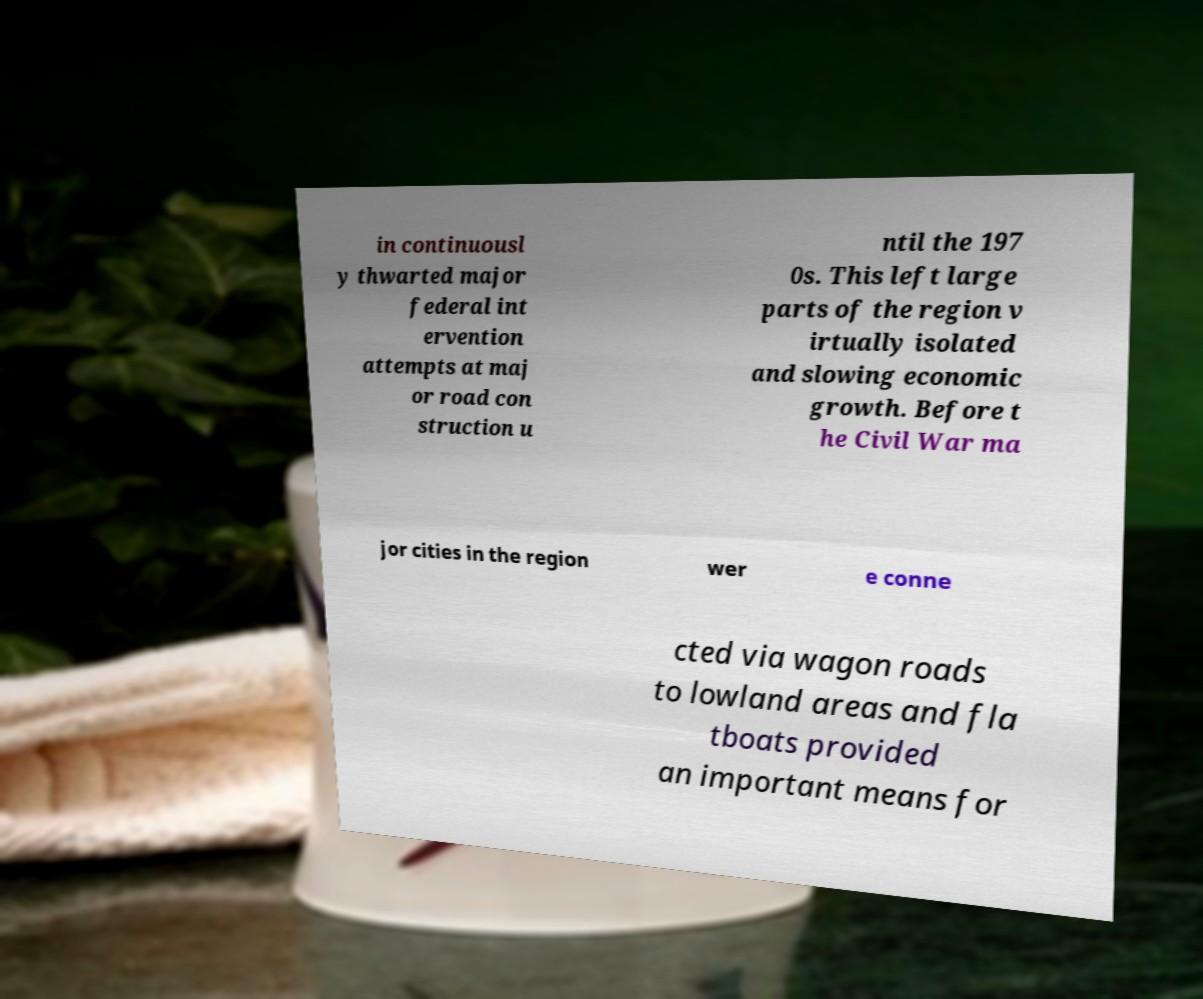Can you read and provide the text displayed in the image?This photo seems to have some interesting text. Can you extract and type it out for me? in continuousl y thwarted major federal int ervention attempts at maj or road con struction u ntil the 197 0s. This left large parts of the region v irtually isolated and slowing economic growth. Before t he Civil War ma jor cities in the region wer e conne cted via wagon roads to lowland areas and fla tboats provided an important means for 